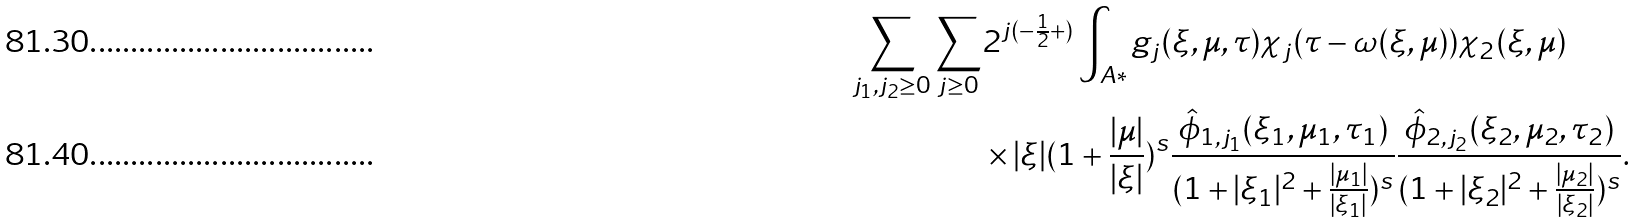<formula> <loc_0><loc_0><loc_500><loc_500>\sum _ { j _ { 1 } , j _ { 2 } \geq 0 } \sum _ { j \geq 0 } & 2 ^ { j ( - \frac { 1 } { 2 } + ) } \int _ { A * } g _ { j } ( \xi , \mu , \tau ) \chi _ { j } ( \tau - \omega ( \xi , \mu ) ) \chi _ { 2 } ( \xi , \mu ) \\ & \times | \xi | ( 1 + \frac { | \mu | } { | \xi | } ) ^ { s } \frac { \hat { \phi } _ { 1 , j _ { 1 } } ( \xi _ { 1 } , \mu _ { 1 } , \tau _ { 1 } ) } { ( 1 + | \xi _ { 1 } | ^ { 2 } + \frac { | \mu _ { 1 } | } { | \xi _ { 1 } | } ) ^ { s } } \frac { \hat { \phi } _ { 2 , j _ { 2 } } ( \xi _ { 2 } , \mu _ { 2 } , \tau _ { 2 } ) } { ( 1 + | \xi _ { 2 } | ^ { 2 } + \frac { | \mu _ { 2 } | } { | \xi _ { 2 } | } ) ^ { s } } .</formula> 